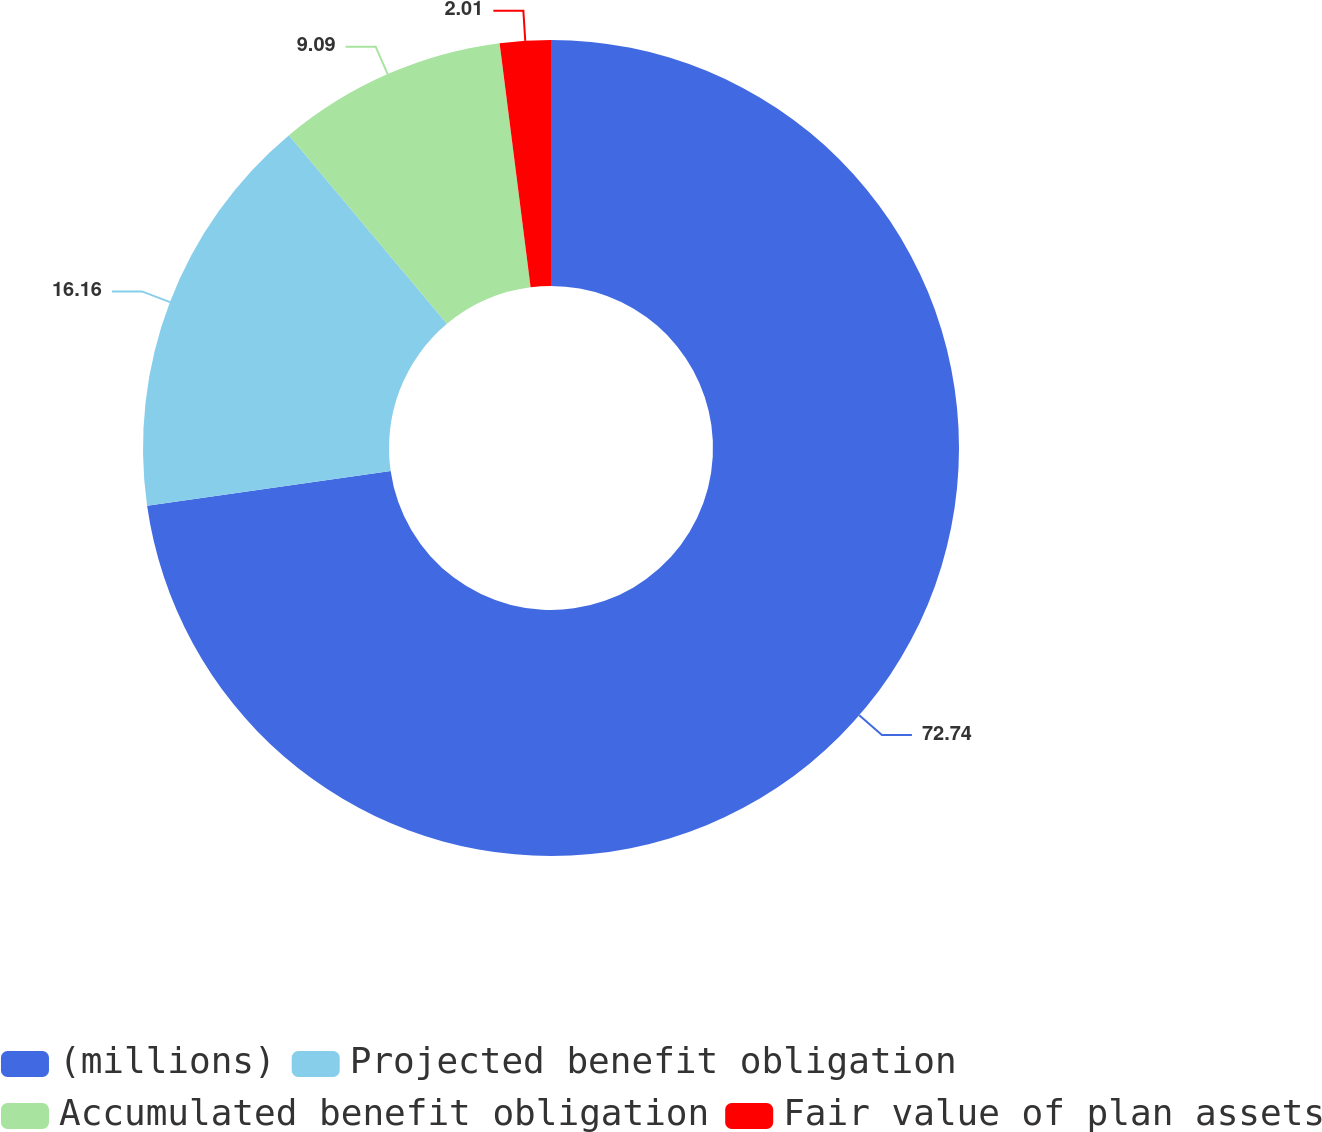Convert chart to OTSL. <chart><loc_0><loc_0><loc_500><loc_500><pie_chart><fcel>(millions)<fcel>Projected benefit obligation<fcel>Accumulated benefit obligation<fcel>Fair value of plan assets<nl><fcel>72.74%<fcel>16.16%<fcel>9.09%<fcel>2.01%<nl></chart> 